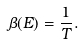Convert formula to latex. <formula><loc_0><loc_0><loc_500><loc_500>\beta ( E ) = \frac { 1 } { T } .</formula> 